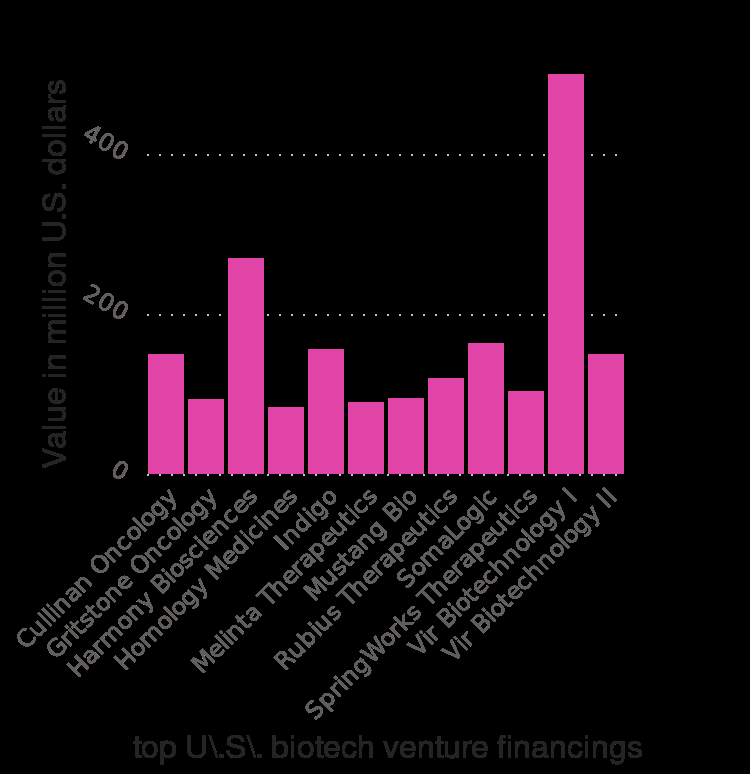<image>
What does the x-axis of the bar plot represent?  The x-axis of the bar plot represents the top U.S. biotech venture financings, listed from Cullinan Oncology to [unspecified value]. please summary the statistics and relations of the chart Vir Biotechnology I is very obviously the highest value US biotech venture finance in 2017 with a value of 500 Million US dollars. The next highest is Harmony Biosciences with a value between 200-400 million US dollars and all the other venture finances sit below the 200 million US dollar line. please describe the details of the chart Value of the top U.S. biotech venture financings in 2017 (in million U.S. dollars) is a bar plot. The y-axis shows Value in million U.S. dollars along linear scale with a minimum of 0 and a maximum of 400 while the x-axis shows top U\.S\. biotech venture financings with categorical scale from Cullinan Oncology to . Does the y-axis of the bar plot represent the top U.S. biotech venture financings listed from Cullinan Oncology to [unspecified value]? No. The x-axis of the bar plot represents the top U.S. biotech venture financings, listed from Cullinan Oncology to [unspecified value]. 